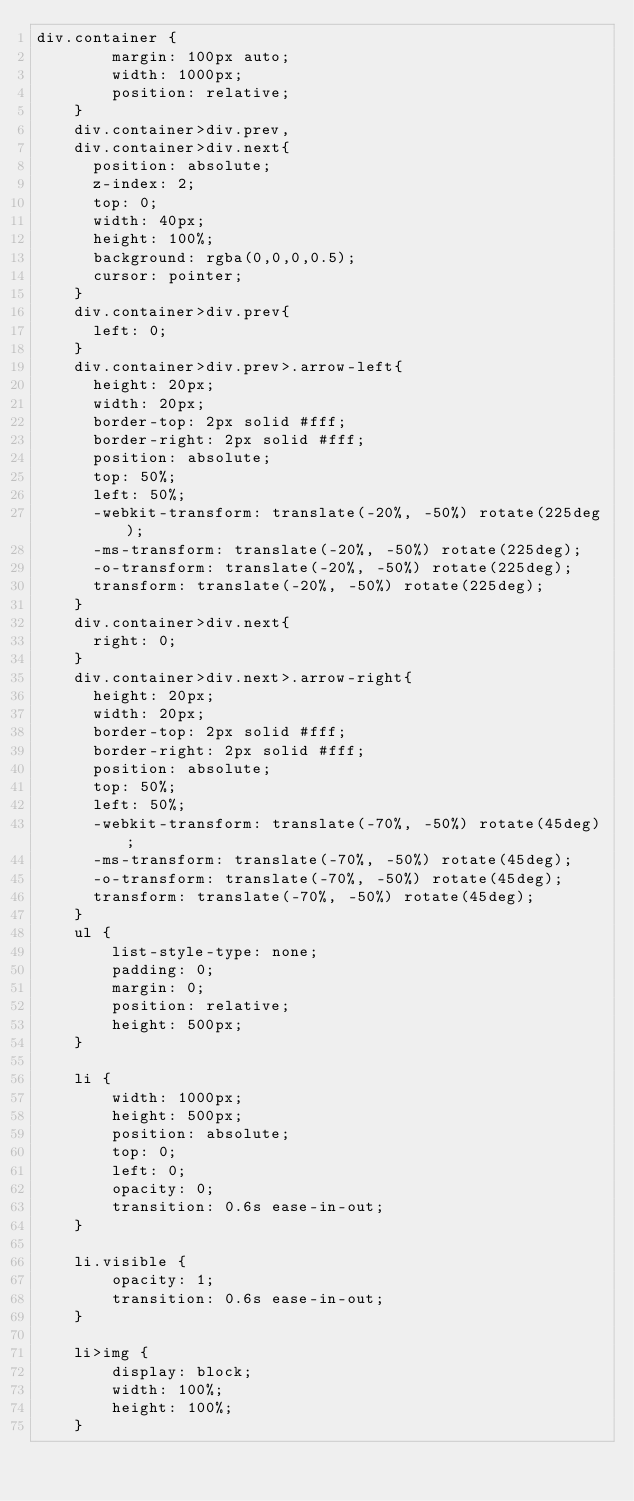<code> <loc_0><loc_0><loc_500><loc_500><_CSS_>div.container {
        margin: 100px auto;
        width: 1000px;
        position: relative;
    }
    div.container>div.prev,
    div.container>div.next{
    	position: absolute;
    	z-index: 2;
    	top: 0;
   		width: 40px;
   		height: 100%;
   		background: rgba(0,0,0,0.5);
   		cursor: pointer;
    }
    div.container>div.prev{
    	left: 0;
    }
    div.container>div.prev>.arrow-left{
    	height: 20px;
    	width: 20px;
    	border-top: 2px solid #fff;
    	border-right: 2px solid #fff;
    	position: absolute;
    	top: 50%;
    	left: 50%;
    	-webkit-transform: translate(-20%, -50%) rotate(225deg);
    	-ms-transform: translate(-20%, -50%) rotate(225deg);
    	-o-transform: translate(-20%, -50%) rotate(225deg);
    	transform: translate(-20%, -50%) rotate(225deg);
    }
    div.container>div.next{
    	right: 0;
    }
    div.container>div.next>.arrow-right{
    	height: 20px;
    	width: 20px;
    	border-top: 2px solid #fff;
    	border-right: 2px solid #fff;
    	position: absolute;
    	top: 50%;
    	left: 50%;
    	-webkit-transform: translate(-70%, -50%) rotate(45deg);
    	-ms-transform: translate(-70%, -50%) rotate(45deg);
    	-o-transform: translate(-70%, -50%) rotate(45deg);
    	transform: translate(-70%, -50%) rotate(45deg);
    }
    ul {
        list-style-type: none;
        padding: 0;
        margin: 0;
        position: relative;
        height: 500px;
    }
    
    li {
        width: 1000px;
        height: 500px;
        position: absolute;
        top: 0;
        left: 0;
        opacity: 0;
        transition: 0.6s ease-in-out;
    }
    
    li.visible {
        opacity: 1;
        transition: 0.6s ease-in-out;
    }
    
    li>img {
        display: block;
        width: 100%;
        height: 100%;
    }</code> 